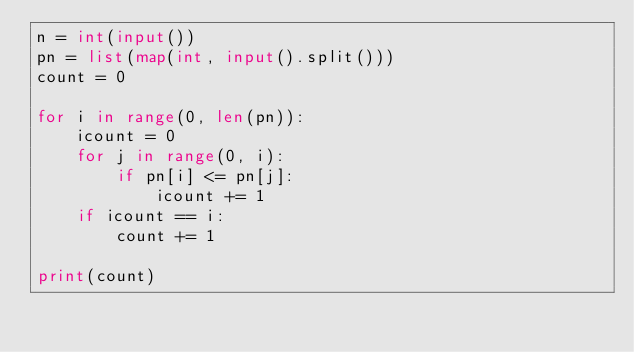<code> <loc_0><loc_0><loc_500><loc_500><_Python_>n = int(input())
pn = list(map(int, input().split()))
count = 0

for i in range(0, len(pn)):
    icount = 0
    for j in range(0, i):
        if pn[i] <= pn[j]:
            icount += 1
    if icount == i:
        count += 1

print(count)</code> 